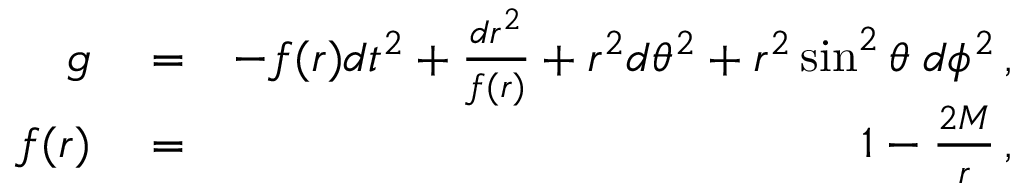<formula> <loc_0><loc_0><loc_500><loc_500>\begin{array} { r l r } { g } & = } & { - f ( r ) d t ^ { 2 } + \frac { d r ^ { 2 } } { f ( r ) } + r ^ { 2 } d \theta ^ { 2 } + r ^ { 2 } \sin ^ { 2 } \theta \, d \phi ^ { 2 } \, , } \\ { f ( r ) } & = } & { 1 - \frac { 2 M } { r } \, , } \end{array}</formula> 